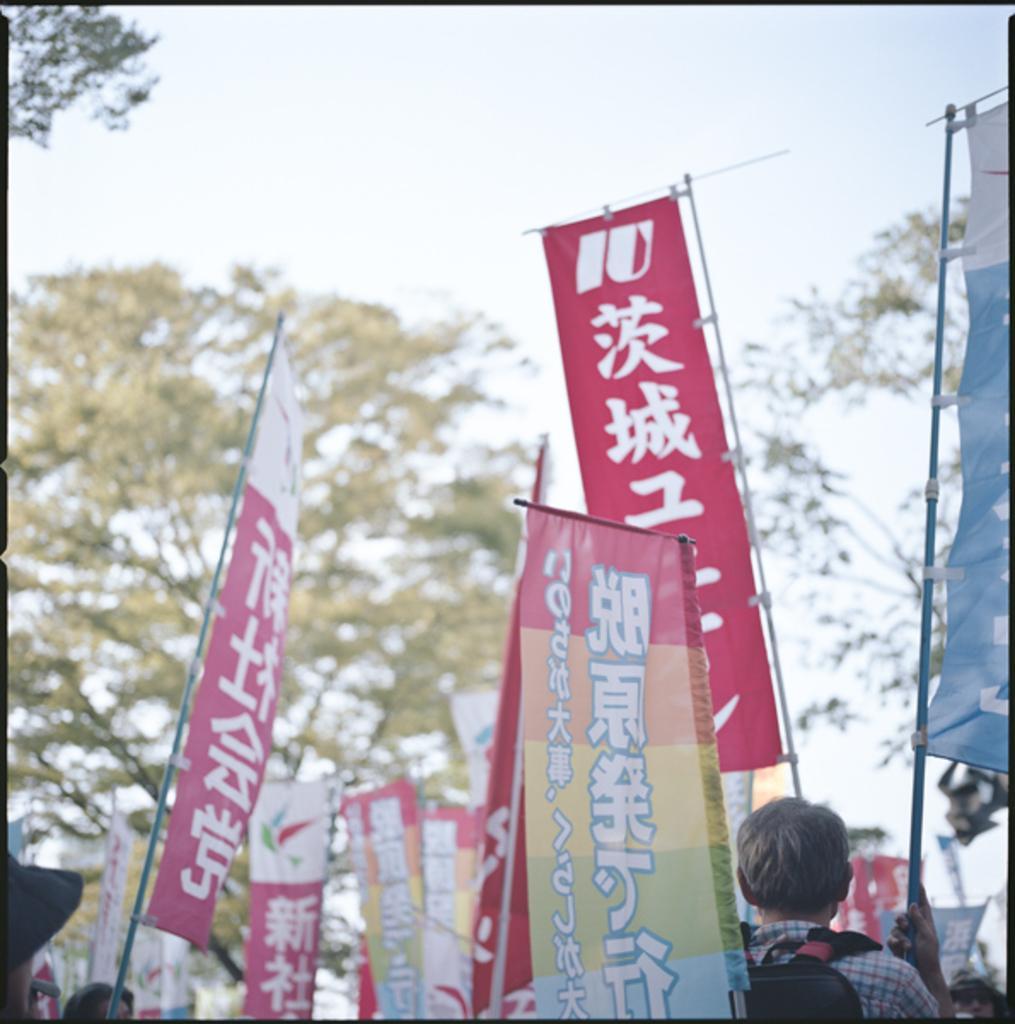Can you describe this image briefly? In the center of the image we can see boards, trees are there. At the bottom of the image we can see some persons are holding the boards. At the top of the image sky is there. 